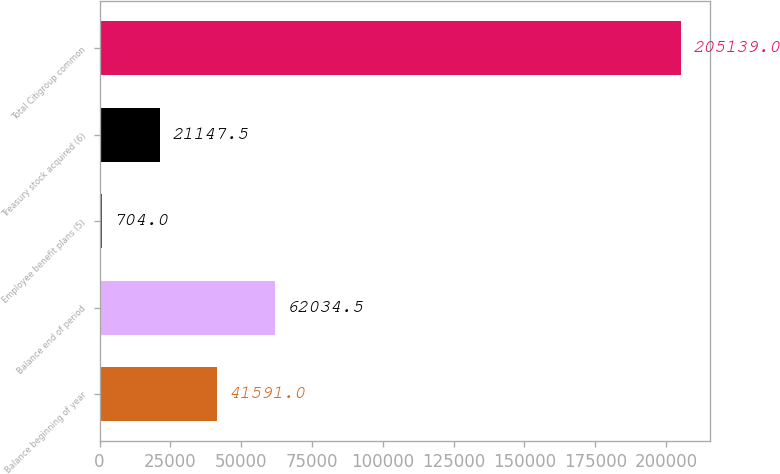Convert chart to OTSL. <chart><loc_0><loc_0><loc_500><loc_500><bar_chart><fcel>Balance beginning of year<fcel>Balance end of period<fcel>Employee benefit plans (5)<fcel>Treasury stock acquired (6)<fcel>Total Citigroup common<nl><fcel>41591<fcel>62034.5<fcel>704<fcel>21147.5<fcel>205139<nl></chart> 